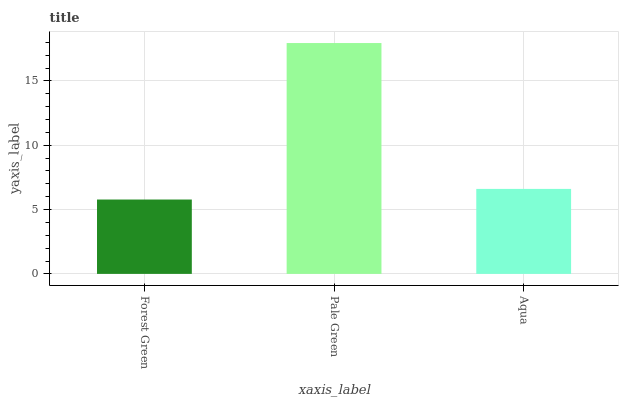Is Forest Green the minimum?
Answer yes or no. Yes. Is Pale Green the maximum?
Answer yes or no. Yes. Is Aqua the minimum?
Answer yes or no. No. Is Aqua the maximum?
Answer yes or no. No. Is Pale Green greater than Aqua?
Answer yes or no. Yes. Is Aqua less than Pale Green?
Answer yes or no. Yes. Is Aqua greater than Pale Green?
Answer yes or no. No. Is Pale Green less than Aqua?
Answer yes or no. No. Is Aqua the high median?
Answer yes or no. Yes. Is Aqua the low median?
Answer yes or no. Yes. Is Forest Green the high median?
Answer yes or no. No. Is Forest Green the low median?
Answer yes or no. No. 